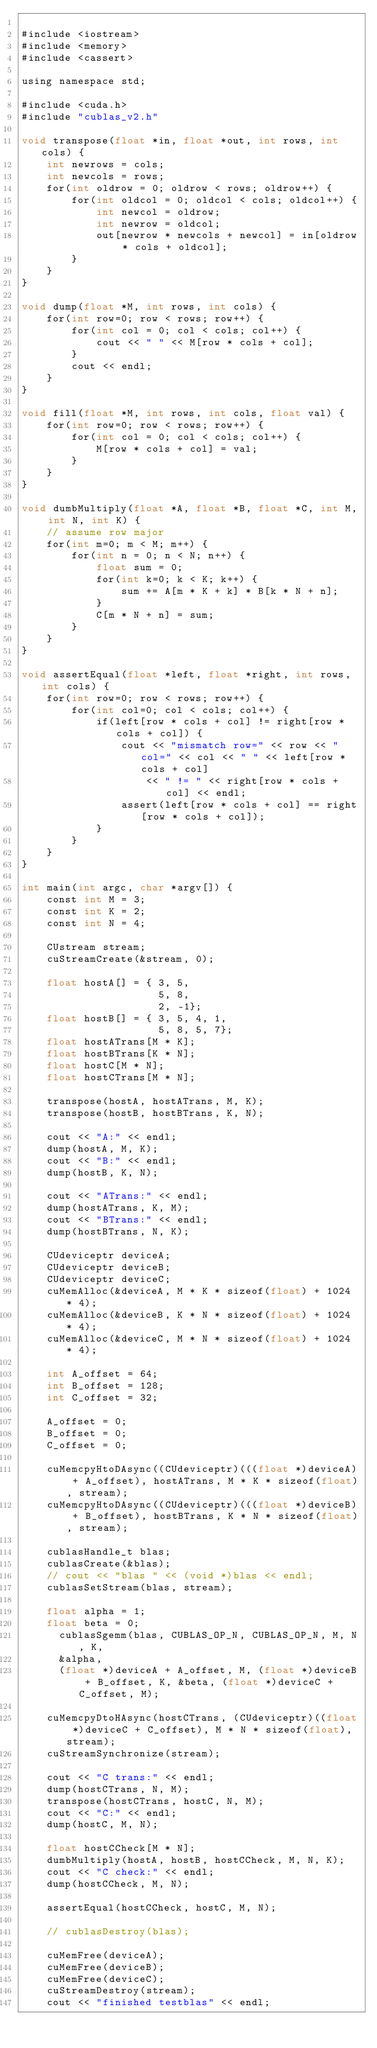<code> <loc_0><loc_0><loc_500><loc_500><_Cuda_>
#include <iostream>
#include <memory>
#include <cassert>

using namespace std;

#include <cuda.h>
#include "cublas_v2.h"

void transpose(float *in, float *out, int rows, int cols) {
    int newrows = cols;
    int newcols = rows;
    for(int oldrow = 0; oldrow < rows; oldrow++) {
        for(int oldcol = 0; oldcol < cols; oldcol++) {
            int newcol = oldrow;
            int newrow = oldcol;
            out[newrow * newcols + newcol] = in[oldrow * cols + oldcol];
        }
    }
}

void dump(float *M, int rows, int cols) {
    for(int row=0; row < rows; row++) {
        for(int col = 0; col < cols; col++) {
            cout << " " << M[row * cols + col];
        }
        cout << endl;
    }
}

void fill(float *M, int rows, int cols, float val) {
    for(int row=0; row < rows; row++) {
        for(int col = 0; col < cols; col++) {
            M[row * cols + col] = val;
        }
    }
}

void dumbMultiply(float *A, float *B, float *C, int M, int N, int K) {
    // assume row major
    for(int m=0; m < M; m++) {
        for(int n = 0; n < N; n++) {
            float sum = 0;
            for(int k=0; k < K; k++) {
                sum += A[m * K + k] * B[k * N + n];
            }
            C[m * N + n] = sum;
        }
    }
}

void assertEqual(float *left, float *right, int rows, int cols) {
    for(int row=0; row < rows; row++) {
        for(int col=0; col < cols; col++) {
            if(left[row * cols + col] != right[row * cols + col]) {
                cout << "mismatch row=" << row << " col=" << col << " " << left[row * cols + col]
                    << " != " << right[row * cols + col] << endl;
                assert(left[row * cols + col] == right[row * cols + col]);
            }
        }
    }
}

int main(int argc, char *argv[]) {
    const int M = 3;
    const int K = 2;
    const int N = 4;

    CUstream stream;
    cuStreamCreate(&stream, 0);

    float hostA[] = { 3, 5,
                      5, 8,
                      2, -1};
    float hostB[] = { 3, 5, 4, 1,
                      5, 8, 5, 7};
    float hostATrans[M * K];
    float hostBTrans[K * N];
    float hostC[M * N];
    float hostCTrans[M * N];

    transpose(hostA, hostATrans, M, K);
    transpose(hostB, hostBTrans, K, N);

    cout << "A:" << endl;
    dump(hostA, M, K);
    cout << "B:" << endl;
    dump(hostB, K, N);

    cout << "ATrans:" << endl;
    dump(hostATrans, K, M);
    cout << "BTrans:" << endl;
    dump(hostBTrans, N, K);

    CUdeviceptr deviceA;
    CUdeviceptr deviceB;
    CUdeviceptr deviceC;
    cuMemAlloc(&deviceA, M * K * sizeof(float) + 1024 * 4);
    cuMemAlloc(&deviceB, K * N * sizeof(float) + 1024 * 4);
    cuMemAlloc(&deviceC, M * N * sizeof(float) + 1024 * 4);

    int A_offset = 64;
    int B_offset = 128;
    int C_offset = 32;

    A_offset = 0;
    B_offset = 0;
    C_offset = 0;

    cuMemcpyHtoDAsync((CUdeviceptr)(((float *)deviceA) + A_offset), hostATrans, M * K * sizeof(float), stream);
    cuMemcpyHtoDAsync((CUdeviceptr)(((float *)deviceB) + B_offset), hostBTrans, K * N * sizeof(float), stream);

    cublasHandle_t blas;
    cublasCreate(&blas);
    // cout << "blas " << (void *)blas << endl;
    cublasSetStream(blas, stream);

    float alpha = 1;
    float beta = 0;
      cublasSgemm(blas, CUBLAS_OP_N, CUBLAS_OP_N, M, N, K,
      &alpha,
      (float *)deviceA + A_offset, M, (float *)deviceB + B_offset, K, &beta, (float *)deviceC + C_offset, M);

    cuMemcpyDtoHAsync(hostCTrans, (CUdeviceptr)((float *)deviceC + C_offset), M * N * sizeof(float), stream);
    cuStreamSynchronize(stream);

    cout << "C trans:" << endl;
    dump(hostCTrans, N, M);
    transpose(hostCTrans, hostC, N, M);
    cout << "C:" << endl;
    dump(hostC, M, N);

    float hostCCheck[M * N];
    dumbMultiply(hostA, hostB, hostCCheck, M, N, K);
    cout << "C check:" << endl;
    dump(hostCCheck, M, N);

    assertEqual(hostCCheck, hostC, M, N);

    // cublasDestroy(blas);

    cuMemFree(deviceA);
    cuMemFree(deviceB);
    cuMemFree(deviceC);
    cuStreamDestroy(stream);
    cout << "finished testblas" << endl;
</code> 